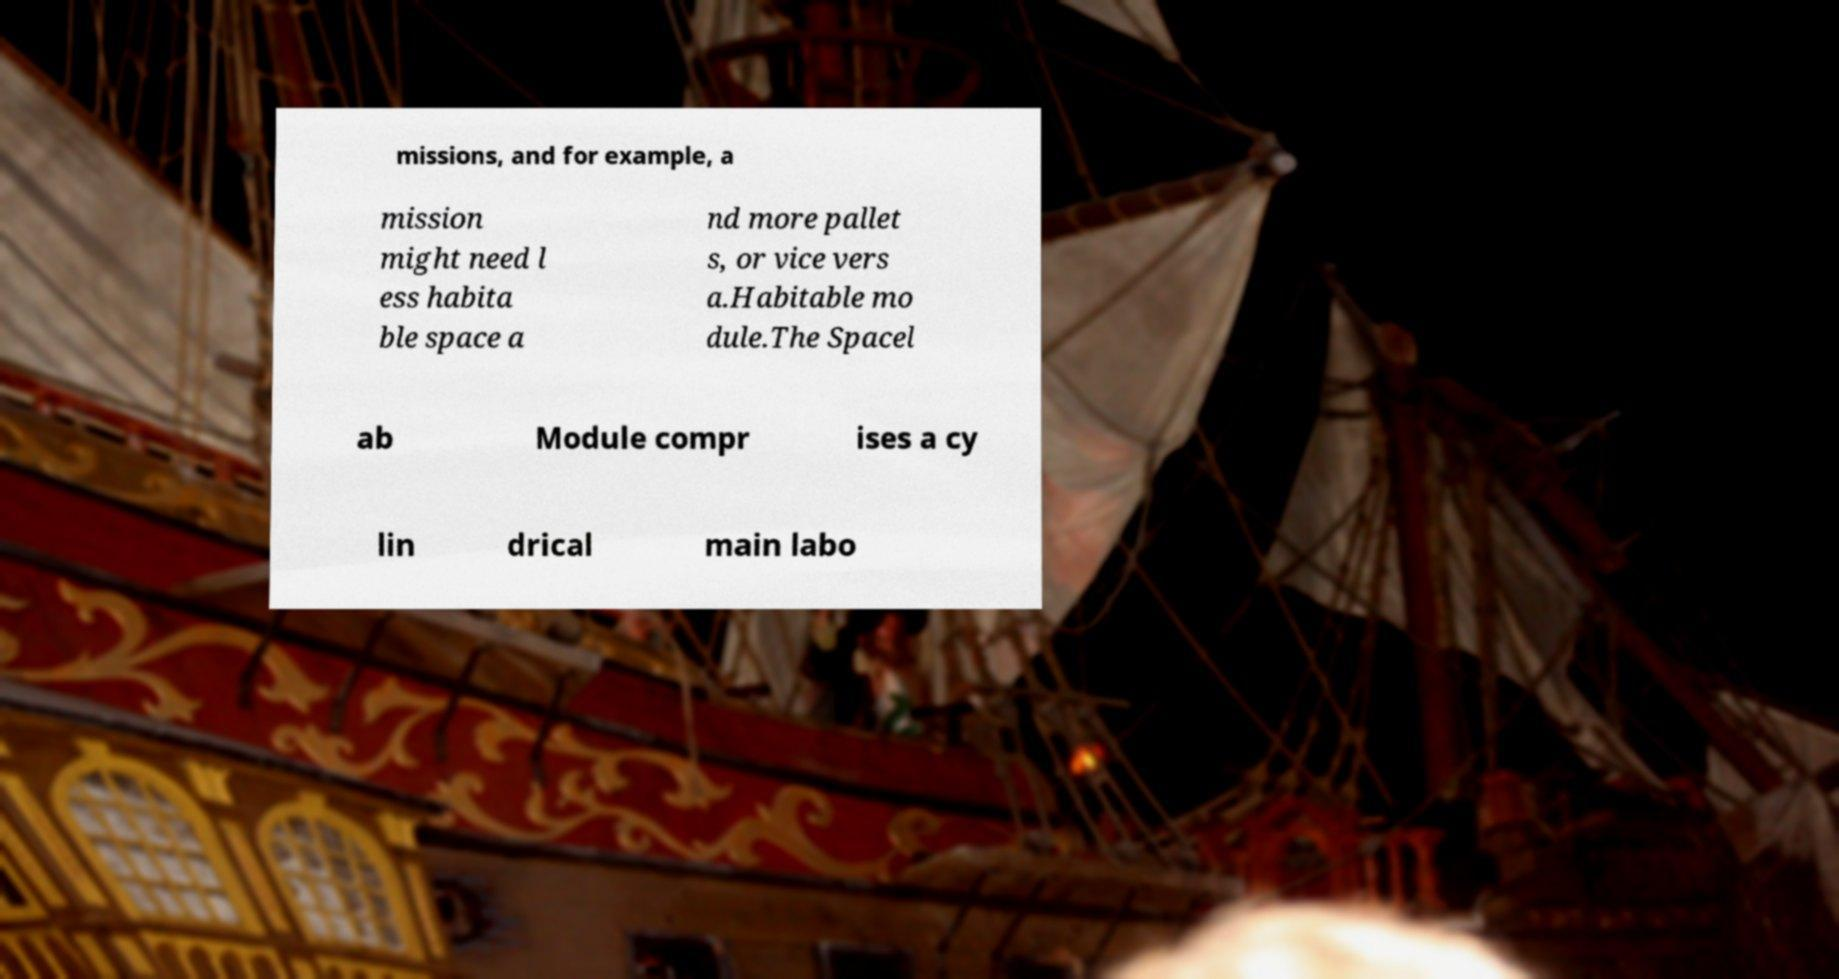For documentation purposes, I need the text within this image transcribed. Could you provide that? missions, and for example, a mission might need l ess habita ble space a nd more pallet s, or vice vers a.Habitable mo dule.The Spacel ab Module compr ises a cy lin drical main labo 